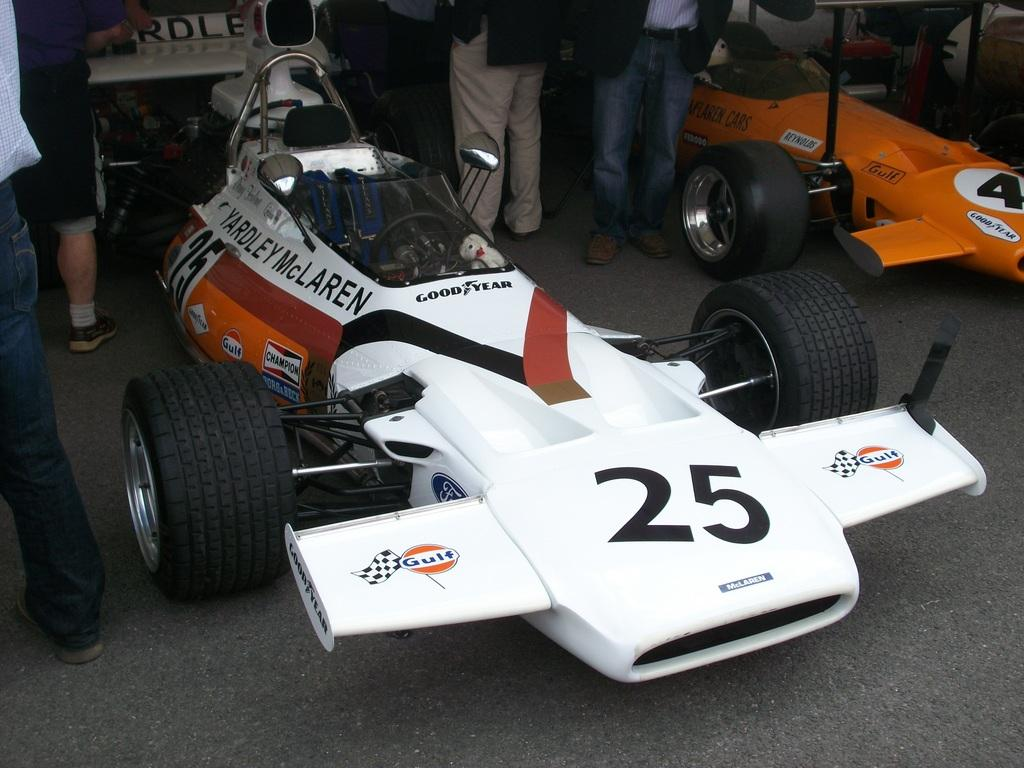What type of vehicles are in the image? There are sport cars in the image. What can be seen on the surface of the cars? There is text visible on the cars. Can you describe the people behind the cars? There are persons visible behind the cars, although they are truncated. What type of request can be seen on the face of the car? There is no face on the car, and therefore no request can be seen. 